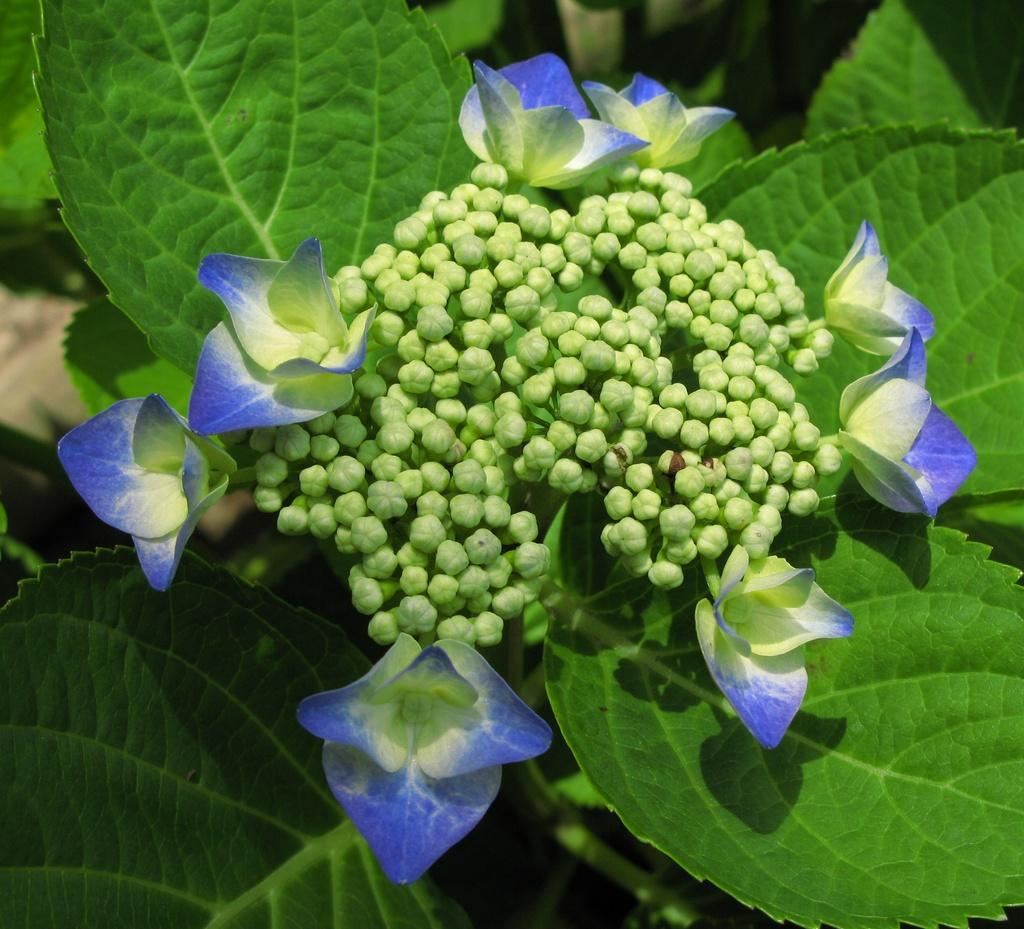What is the main subject of the image? The main subject of the image is a group of flowers. Can you describe any specific features of the flowers? There are buds on a plant in the image. What type of army can be seen marching through the cave in the image? There is no army or cave present in the image; it features a group of flowers with buds on a plant. 